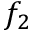<formula> <loc_0><loc_0><loc_500><loc_500>f _ { 2 }</formula> 